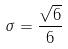<formula> <loc_0><loc_0><loc_500><loc_500>\sigma = \frac { \sqrt { 6 } } { 6 }</formula> 